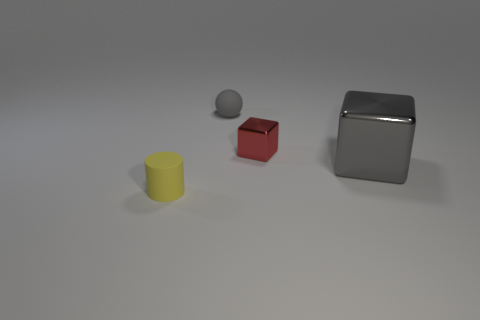Do the tiny matte object behind the gray cube and the big object have the same color? Based on the image, it's difficult to definitively say if the tiny object behind the gray cube and the larger object share the same color. Due to lighting and shadows, colors can seem different in photos depending on their surroundings and texture. While the two objects might appear to have a similar hue, variations in material finish and light reflection may affect color perception. 